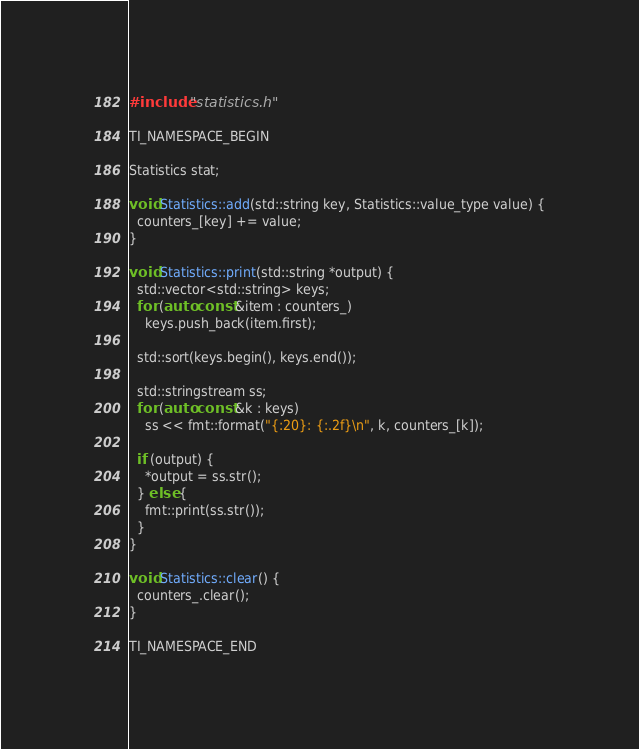<code> <loc_0><loc_0><loc_500><loc_500><_C++_>#include "statistics.h"

TI_NAMESPACE_BEGIN

Statistics stat;

void Statistics::add(std::string key, Statistics::value_type value) {
  counters_[key] += value;
}

void Statistics::print(std::string *output) {
  std::vector<std::string> keys;
  for (auto const &item : counters_)
    keys.push_back(item.first);

  std::sort(keys.begin(), keys.end());

  std::stringstream ss;
  for (auto const &k : keys)
    ss << fmt::format("{:20}: {:.2f}\n", k, counters_[k]);

  if (output) {
    *output = ss.str();
  } else {
    fmt::print(ss.str());
  }
}

void Statistics::clear() {
  counters_.clear();
}

TI_NAMESPACE_END
</code> 